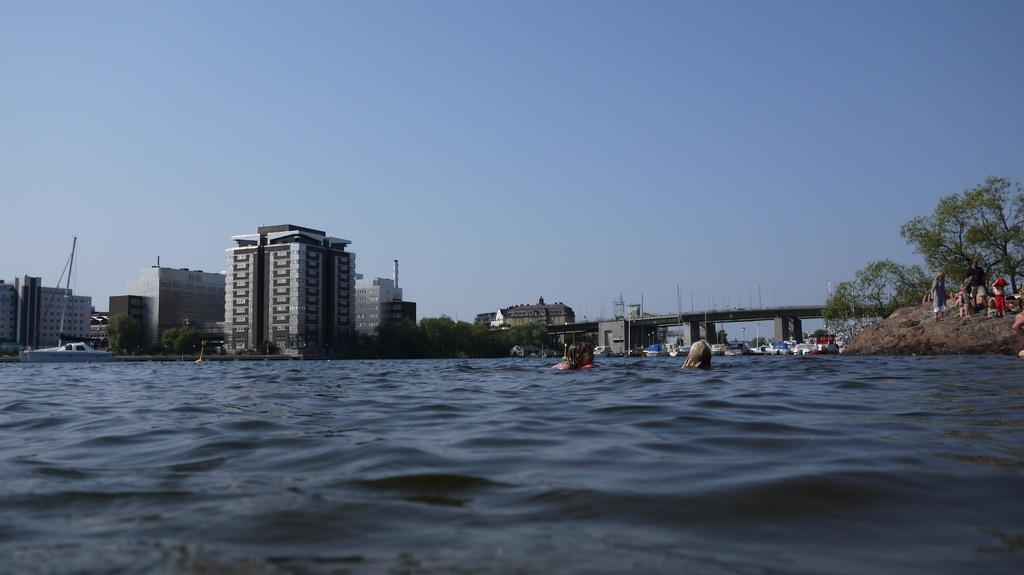Could you give a brief overview of what you see in this image? In this image we can see few persons in the water. Behind the water we can see a group of buildings, trees, boats and a bridge. At the top we can see the sky. On the right side of the image we can see few trees, persons and a rock. 